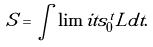Convert formula to latex. <formula><loc_0><loc_0><loc_500><loc_500>S = \int \lim i t s _ { 0 } ^ { t } L d t .</formula> 